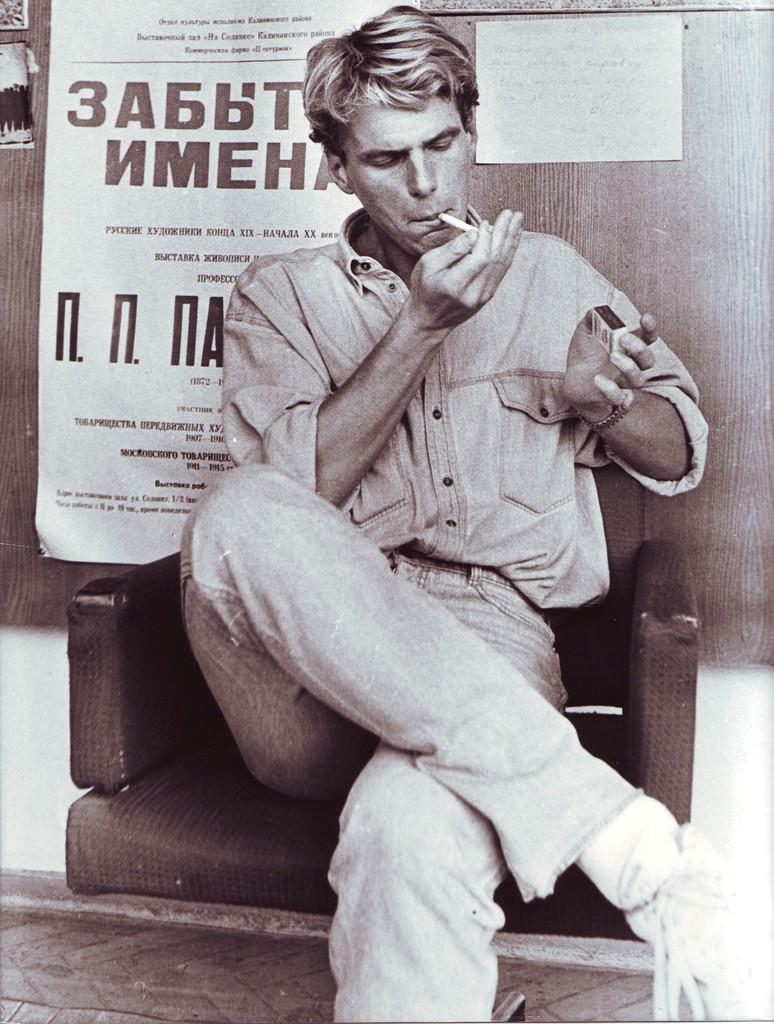What is the color scheme of the image? The image is black and white. Who is present in the image? There is a man in the image. What is the man doing in the image? The man is sitting on a chair and smoking a cigarette. What can be seen behind the man? There is a wall behind the man. What is on the wall behind the man? There are posters on the wall. What type of pickle is the man holding in the image? There is no pickle present in the image; the man is smoking a cigarette. How does the man's temper affect the zoo in the image? There is no zoo present in the image, and the man's temper is not mentioned or depicted. 